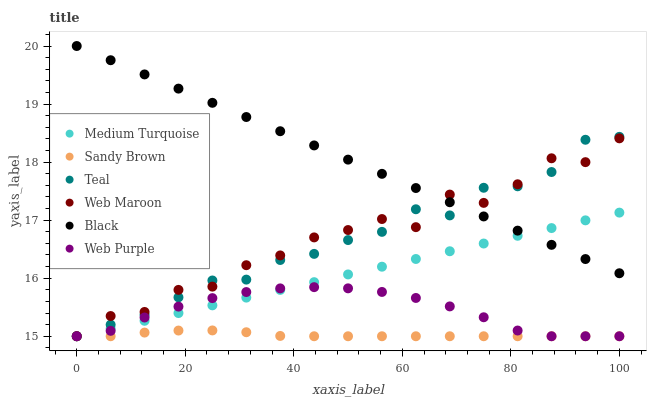Does Sandy Brown have the minimum area under the curve?
Answer yes or no. Yes. Does Black have the maximum area under the curve?
Answer yes or no. Yes. Does Web Maroon have the minimum area under the curve?
Answer yes or no. No. Does Web Maroon have the maximum area under the curve?
Answer yes or no. No. Is Black the smoothest?
Answer yes or no. Yes. Is Web Maroon the roughest?
Answer yes or no. Yes. Is Web Purple the smoothest?
Answer yes or no. No. Is Web Purple the roughest?
Answer yes or no. No. Does Medium Turquoise have the lowest value?
Answer yes or no. Yes. Does Black have the lowest value?
Answer yes or no. No. Does Black have the highest value?
Answer yes or no. Yes. Does Web Maroon have the highest value?
Answer yes or no. No. Is Web Purple less than Black?
Answer yes or no. Yes. Is Black greater than Sandy Brown?
Answer yes or no. Yes. Does Web Purple intersect Sandy Brown?
Answer yes or no. Yes. Is Web Purple less than Sandy Brown?
Answer yes or no. No. Is Web Purple greater than Sandy Brown?
Answer yes or no. No. Does Web Purple intersect Black?
Answer yes or no. No. 